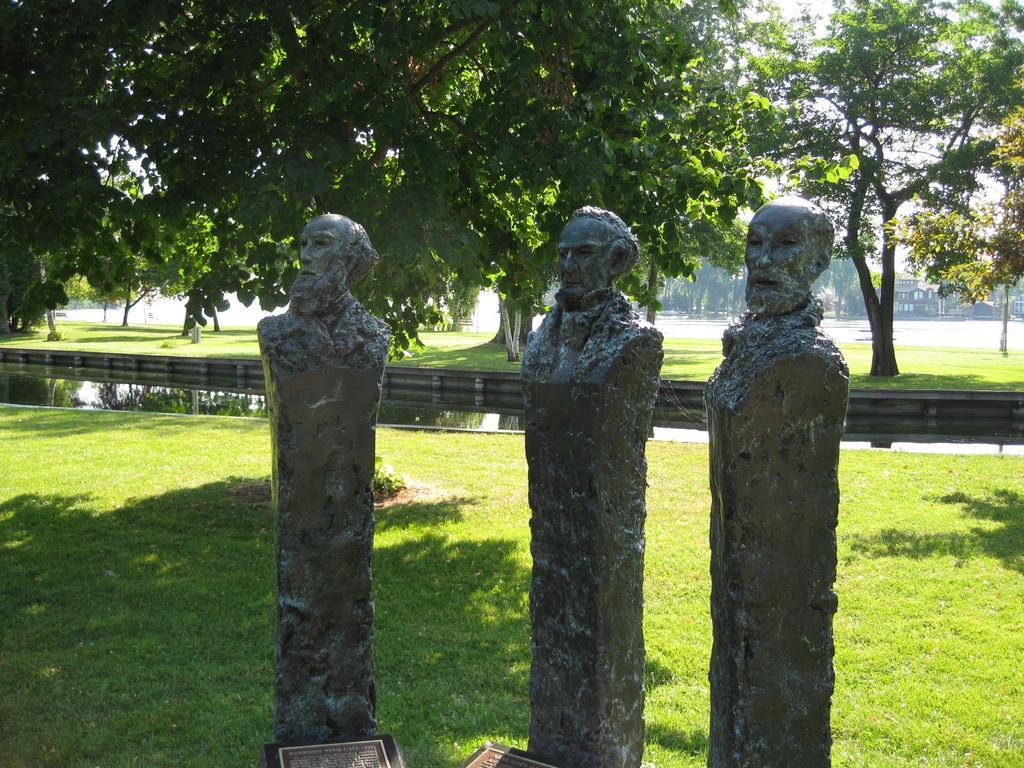How would you summarize this image in a sentence or two? Front of the image we can see status and information boards. Land is covered with grass. Background there is a water, building and trees. 